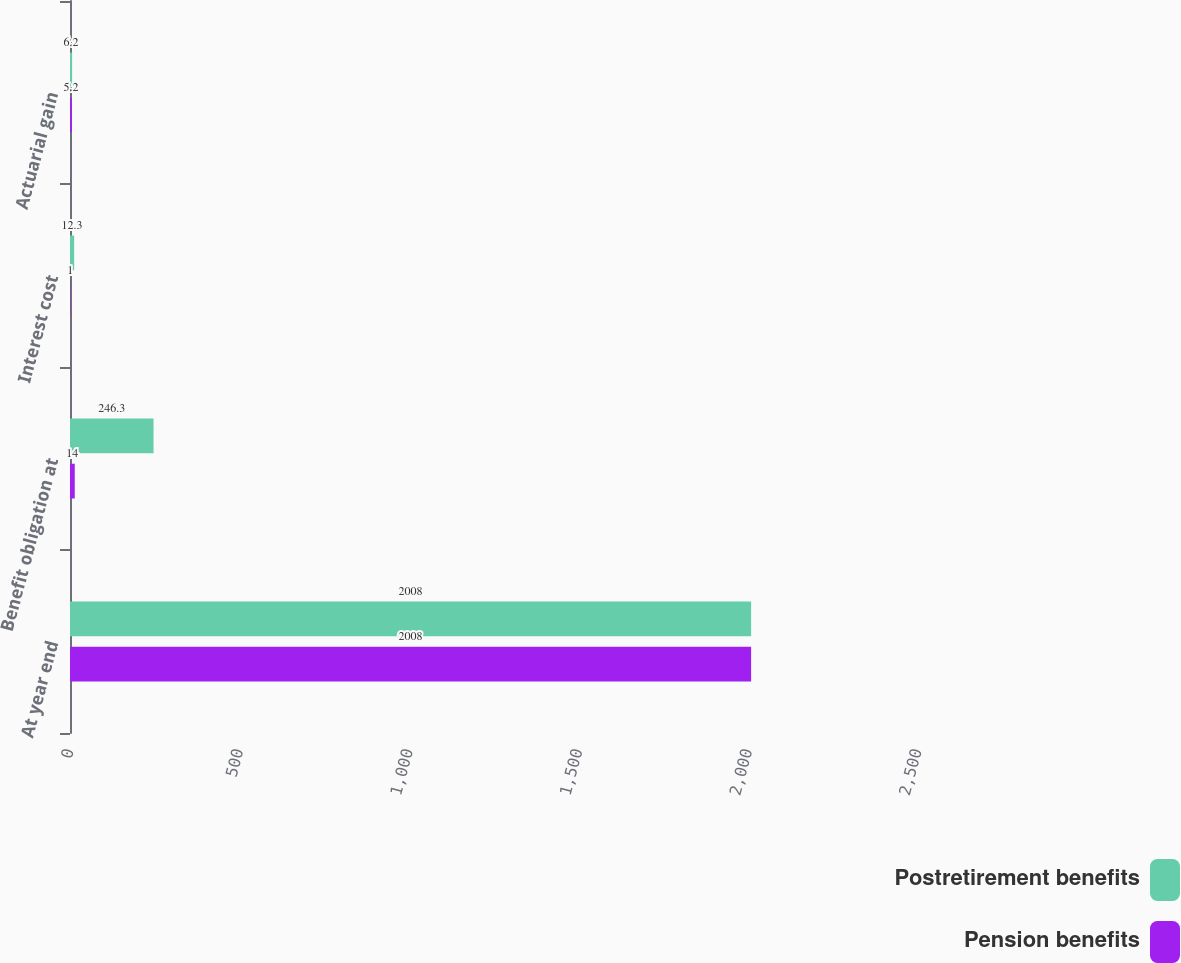Convert chart. <chart><loc_0><loc_0><loc_500><loc_500><stacked_bar_chart><ecel><fcel>At year end<fcel>Benefit obligation at<fcel>Interest cost<fcel>Actuarial gain<nl><fcel>Postretirement benefits<fcel>2008<fcel>246.3<fcel>12.3<fcel>6.2<nl><fcel>Pension benefits<fcel>2008<fcel>14<fcel>1<fcel>5.2<nl></chart> 